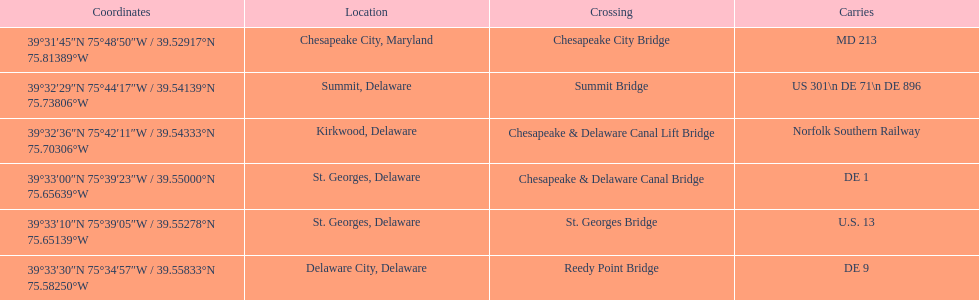Which bridge is in delaware and carries de 9? Reedy Point Bridge. 